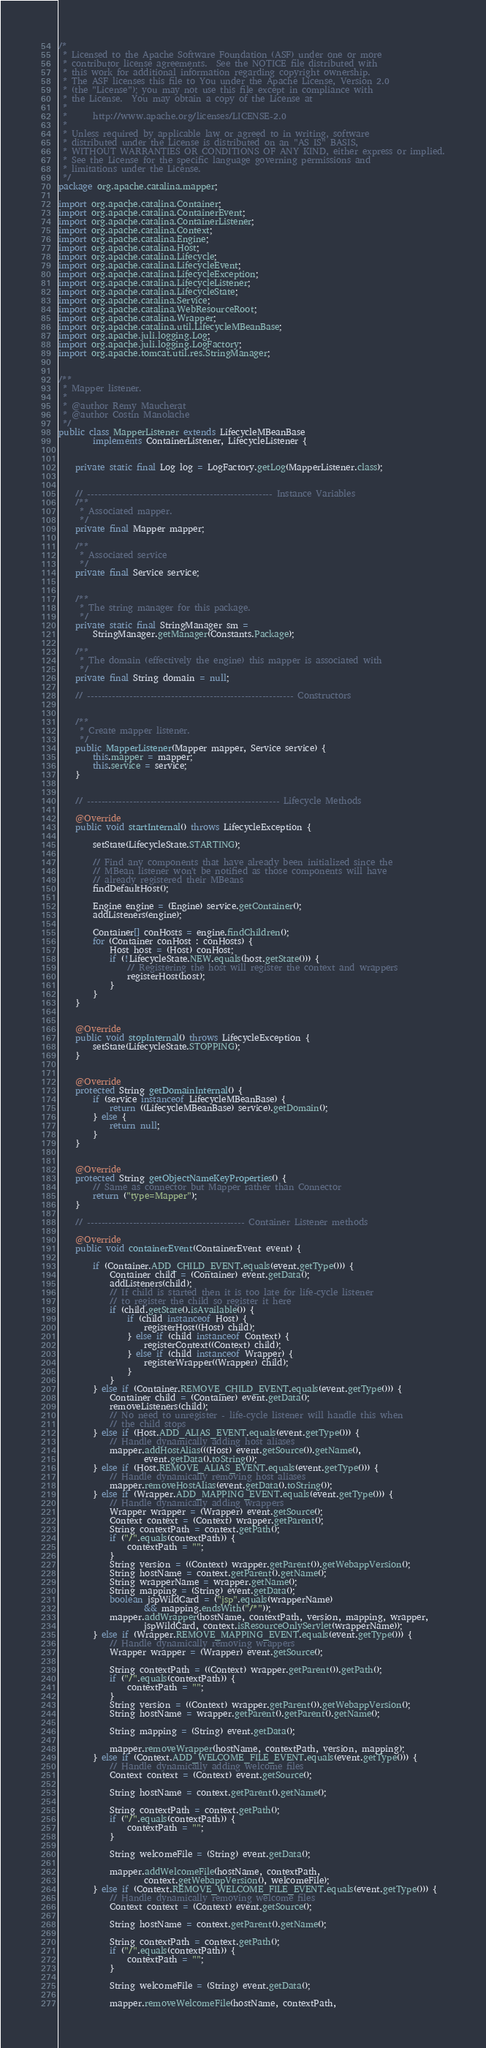<code> <loc_0><loc_0><loc_500><loc_500><_Java_>/*
 * Licensed to the Apache Software Foundation (ASF) under one or more
 * contributor license agreements.  See the NOTICE file distributed with
 * this work for additional information regarding copyright ownership.
 * The ASF licenses this file to You under the Apache License, Version 2.0
 * (the "License"); you may not use this file except in compliance with
 * the License.  You may obtain a copy of the License at
 *
 *      http://www.apache.org/licenses/LICENSE-2.0
 *
 * Unless required by applicable law or agreed to in writing, software
 * distributed under the License is distributed on an "AS IS" BASIS,
 * WITHOUT WARRANTIES OR CONDITIONS OF ANY KIND, either express or implied.
 * See the License for the specific language governing permissions and
 * limitations under the License.
 */
package org.apache.catalina.mapper;

import org.apache.catalina.Container;
import org.apache.catalina.ContainerEvent;
import org.apache.catalina.ContainerListener;
import org.apache.catalina.Context;
import org.apache.catalina.Engine;
import org.apache.catalina.Host;
import org.apache.catalina.Lifecycle;
import org.apache.catalina.LifecycleEvent;
import org.apache.catalina.LifecycleException;
import org.apache.catalina.LifecycleListener;
import org.apache.catalina.LifecycleState;
import org.apache.catalina.Service;
import org.apache.catalina.WebResourceRoot;
import org.apache.catalina.Wrapper;
import org.apache.catalina.util.LifecycleMBeanBase;
import org.apache.juli.logging.Log;
import org.apache.juli.logging.LogFactory;
import org.apache.tomcat.util.res.StringManager;


/**
 * Mapper listener.
 *
 * @author Remy Maucherat
 * @author Costin Manolache
 */
public class MapperListener extends LifecycleMBeanBase
        implements ContainerListener, LifecycleListener {


    private static final Log log = LogFactory.getLog(MapperListener.class);


    // ----------------------------------------------------- Instance Variables
    /**
     * Associated mapper.
     */
    private final Mapper mapper;

    /**
     * Associated service
     */
    private final Service service;


    /**
     * The string manager for this package.
     */
    private static final StringManager sm =
        StringManager.getManager(Constants.Package);

    /**
     * The domain (effectively the engine) this mapper is associated with
     */
    private final String domain = null;

    // ----------------------------------------------------------- Constructors


    /**
     * Create mapper listener.
     */
    public MapperListener(Mapper mapper, Service service) {
        this.mapper = mapper;
        this.service = service;
    }


    // ------------------------------------------------------- Lifecycle Methods

    @Override
    public void startInternal() throws LifecycleException {

        setState(LifecycleState.STARTING);

        // Find any components that have already been initialized since the
        // MBean listener won't be notified as those components will have
        // already registered their MBeans
        findDefaultHost();

        Engine engine = (Engine) service.getContainer();
        addListeners(engine);

        Container[] conHosts = engine.findChildren();
        for (Container conHost : conHosts) {
            Host host = (Host) conHost;
            if (!LifecycleState.NEW.equals(host.getState())) {
                // Registering the host will register the context and wrappers
                registerHost(host);
            }
        }
    }


    @Override
    public void stopInternal() throws LifecycleException {
        setState(LifecycleState.STOPPING);
    }


    @Override
    protected String getDomainInternal() {
        if (service instanceof LifecycleMBeanBase) {
            return ((LifecycleMBeanBase) service).getDomain();
        } else {
            return null;
        }
    }


    @Override
    protected String getObjectNameKeyProperties() {
        // Same as connector but Mapper rather than Connector
        return ("type=Mapper");
    }

    // --------------------------------------------- Container Listener methods

    @Override
    public void containerEvent(ContainerEvent event) {

        if (Container.ADD_CHILD_EVENT.equals(event.getType())) {
            Container child = (Container) event.getData();
            addListeners(child);
            // If child is started then it is too late for life-cycle listener
            // to register the child so register it here
            if (child.getState().isAvailable()) {
                if (child instanceof Host) {
                    registerHost((Host) child);
                } else if (child instanceof Context) {
                    registerContext((Context) child);
                } else if (child instanceof Wrapper) {
                    registerWrapper((Wrapper) child);
                }
            }
        } else if (Container.REMOVE_CHILD_EVENT.equals(event.getType())) {
            Container child = (Container) event.getData();
            removeListeners(child);
            // No need to unregister - life-cycle listener will handle this when
            // the child stops
        } else if (Host.ADD_ALIAS_EVENT.equals(event.getType())) {
            // Handle dynamically adding host aliases
            mapper.addHostAlias(((Host) event.getSource()).getName(),
                    event.getData().toString());
        } else if (Host.REMOVE_ALIAS_EVENT.equals(event.getType())) {
            // Handle dynamically removing host aliases
            mapper.removeHostAlias(event.getData().toString());
        } else if (Wrapper.ADD_MAPPING_EVENT.equals(event.getType())) {
            // Handle dynamically adding wrappers
            Wrapper wrapper = (Wrapper) event.getSource();
            Context context = (Context) wrapper.getParent();
            String contextPath = context.getPath();
            if ("/".equals(contextPath)) {
                contextPath = "";
            }
            String version = ((Context) wrapper.getParent()).getWebappVersion();
            String hostName = context.getParent().getName();
            String wrapperName = wrapper.getName();
            String mapping = (String) event.getData();
            boolean jspWildCard = ("jsp".equals(wrapperName)
                    && mapping.endsWith("/*"));
            mapper.addWrapper(hostName, contextPath, version, mapping, wrapper,
                    jspWildCard, context.isResourceOnlyServlet(wrapperName));
        } else if (Wrapper.REMOVE_MAPPING_EVENT.equals(event.getType())) {
            // Handle dynamically removing wrappers
            Wrapper wrapper = (Wrapper) event.getSource();

            String contextPath = ((Context) wrapper.getParent()).getPath();
            if ("/".equals(contextPath)) {
                contextPath = "";
            }
            String version = ((Context) wrapper.getParent()).getWebappVersion();
            String hostName = wrapper.getParent().getParent().getName();

            String mapping = (String) event.getData();

            mapper.removeWrapper(hostName, contextPath, version, mapping);
        } else if (Context.ADD_WELCOME_FILE_EVENT.equals(event.getType())) {
            // Handle dynamically adding welcome files
            Context context = (Context) event.getSource();

            String hostName = context.getParent().getName();

            String contextPath = context.getPath();
            if ("/".equals(contextPath)) {
                contextPath = "";
            }

            String welcomeFile = (String) event.getData();

            mapper.addWelcomeFile(hostName, contextPath,
                    context.getWebappVersion(), welcomeFile);
        } else if (Context.REMOVE_WELCOME_FILE_EVENT.equals(event.getType())) {
            // Handle dynamically removing welcome files
            Context context = (Context) event.getSource();

            String hostName = context.getParent().getName();

            String contextPath = context.getPath();
            if ("/".equals(contextPath)) {
                contextPath = "";
            }

            String welcomeFile = (String) event.getData();

            mapper.removeWelcomeFile(hostName, contextPath,</code> 